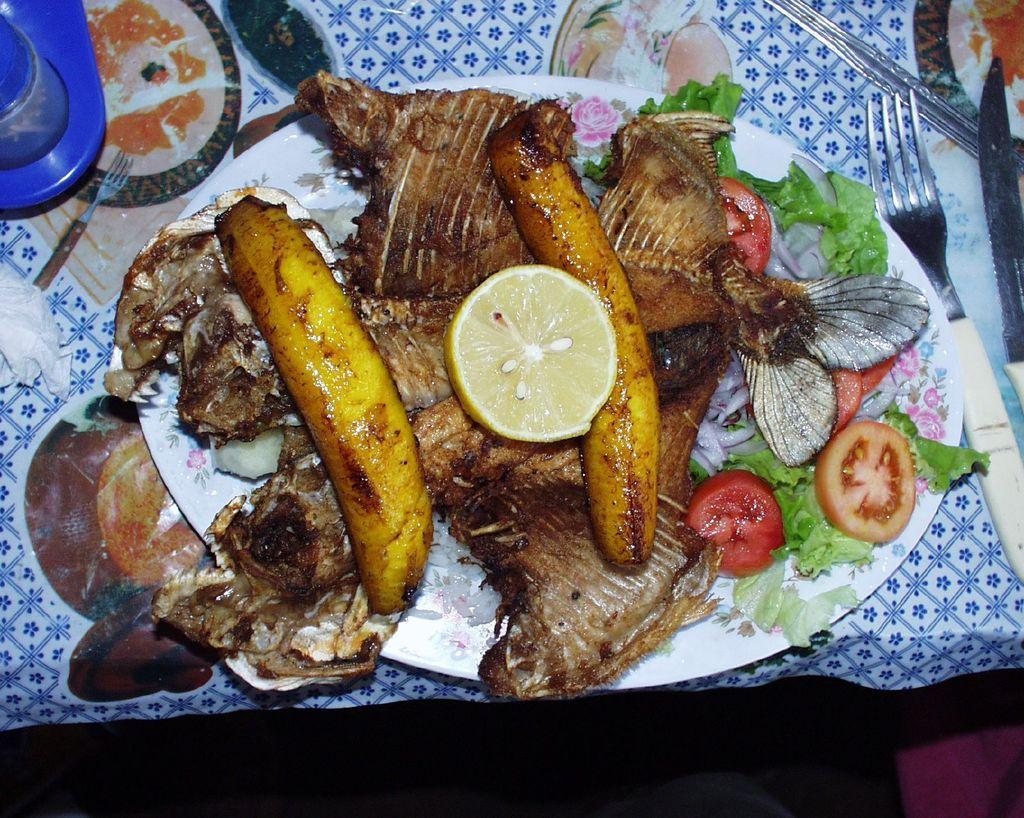Please provide a concise description of this image. In the image in the center, we can see one table. On the table, we can see one cloth, forks, blue color object, plate and some food items. 